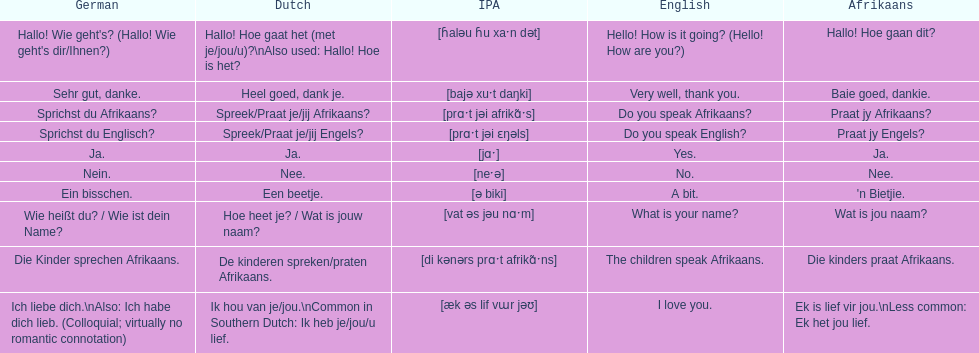How do you say "do you speak afrikaans?" in afrikaans? Praat jy Afrikaans?. 